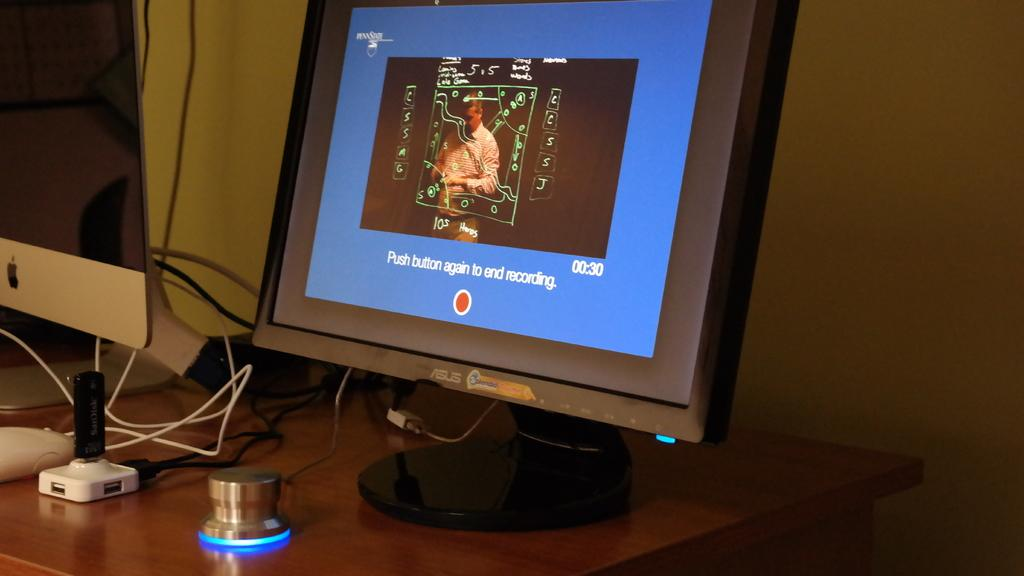Provide a one-sentence caption for the provided image. A computer monitor displaying a prompt to end a recording by pressing a marked button. 